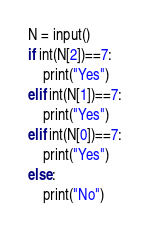Convert code to text. <code><loc_0><loc_0><loc_500><loc_500><_Python_>N = input()
if int(N[2])==7:
    print("Yes")
elif int(N[1])==7:
    print("Yes")
elif int(N[0])==7:
    print("Yes")
else:
    print("No")</code> 